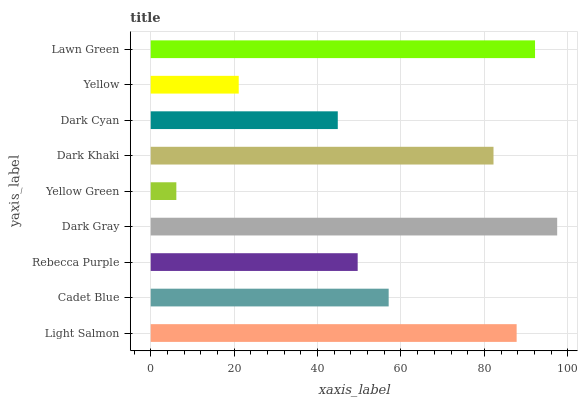Is Yellow Green the minimum?
Answer yes or no. Yes. Is Dark Gray the maximum?
Answer yes or no. Yes. Is Cadet Blue the minimum?
Answer yes or no. No. Is Cadet Blue the maximum?
Answer yes or no. No. Is Light Salmon greater than Cadet Blue?
Answer yes or no. Yes. Is Cadet Blue less than Light Salmon?
Answer yes or no. Yes. Is Cadet Blue greater than Light Salmon?
Answer yes or no. No. Is Light Salmon less than Cadet Blue?
Answer yes or no. No. Is Cadet Blue the high median?
Answer yes or no. Yes. Is Cadet Blue the low median?
Answer yes or no. Yes. Is Rebecca Purple the high median?
Answer yes or no. No. Is Yellow the low median?
Answer yes or no. No. 